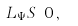<formula> <loc_0><loc_0><loc_500><loc_500>L _ { \Psi } S \doteq 0 \, ,</formula> 